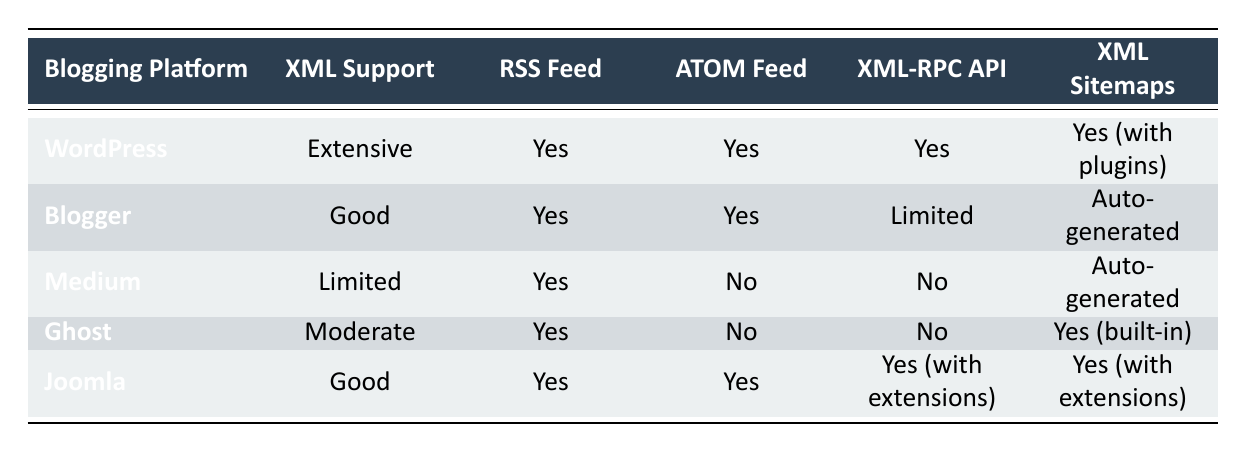What is the XML support level for WordPress? The table indicates that WordPress has "Extensive" XML support.
Answer: Extensive Does Medium offer ATOM Feed support? According to the table, Medium does not support ATOM Feed as it is marked "No."
Answer: No How many blogging platforms have "Good" XML support? The table lists two platforms, Blogger and Joomla, which both have "Good" XML support.
Answer: 2 Which platforms provide both RSS and ATOM feeds? The platforms listed for both RSS and ATOM feeds are WordPress, Blogger, and Joomla based on their respective support in the table.
Answer: WordPress, Blogger, Joomla Which blogging platform offers the XML-RPC API with extensions? Joomla is the only platform mentioned in the table that offers the XML-RPC API with extensions.
Answer: Joomla How many platforms have auto-generated XML sitemaps? The table indicates that Blogger and Medium have auto-generated XML sitemaps, so there are two platforms.
Answer: 2 Is there any platform, among those listed, that does not support XML-RPC API at all? Yes, both Medium and Ghost do not support the XML-RPC API as their entries state "No."
Answer: Yes What is the difference in XML support between Ghost and Medium? Ghost has "Moderate" XML support while Medium has "Limited" XML support, showing a difference in their XML capabilities.
Answer: Moderate vs. Limited Which blogging platform has the best overall XML support? WordPress has the best overall XML support, categorized as "Extensive" in the table.
Answer: WordPress 